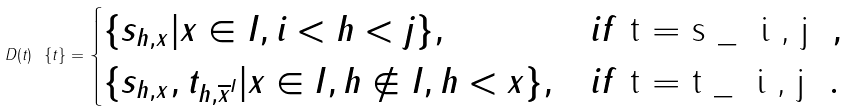<formula> <loc_0><loc_0><loc_500><loc_500>D ( t ) \ \{ t \} = \begin{cases} \{ s _ { h , x } | x \in I , i < h < j \} , & i f $ t = s _ { i , j } $ , \\ \{ s _ { h , x } , t _ { h , { \overline { x } } ^ { I } } | x \in I , h \not \in I , h < x \} , & i f $ t = t _ { i , j } $ . \end{cases}</formula> 